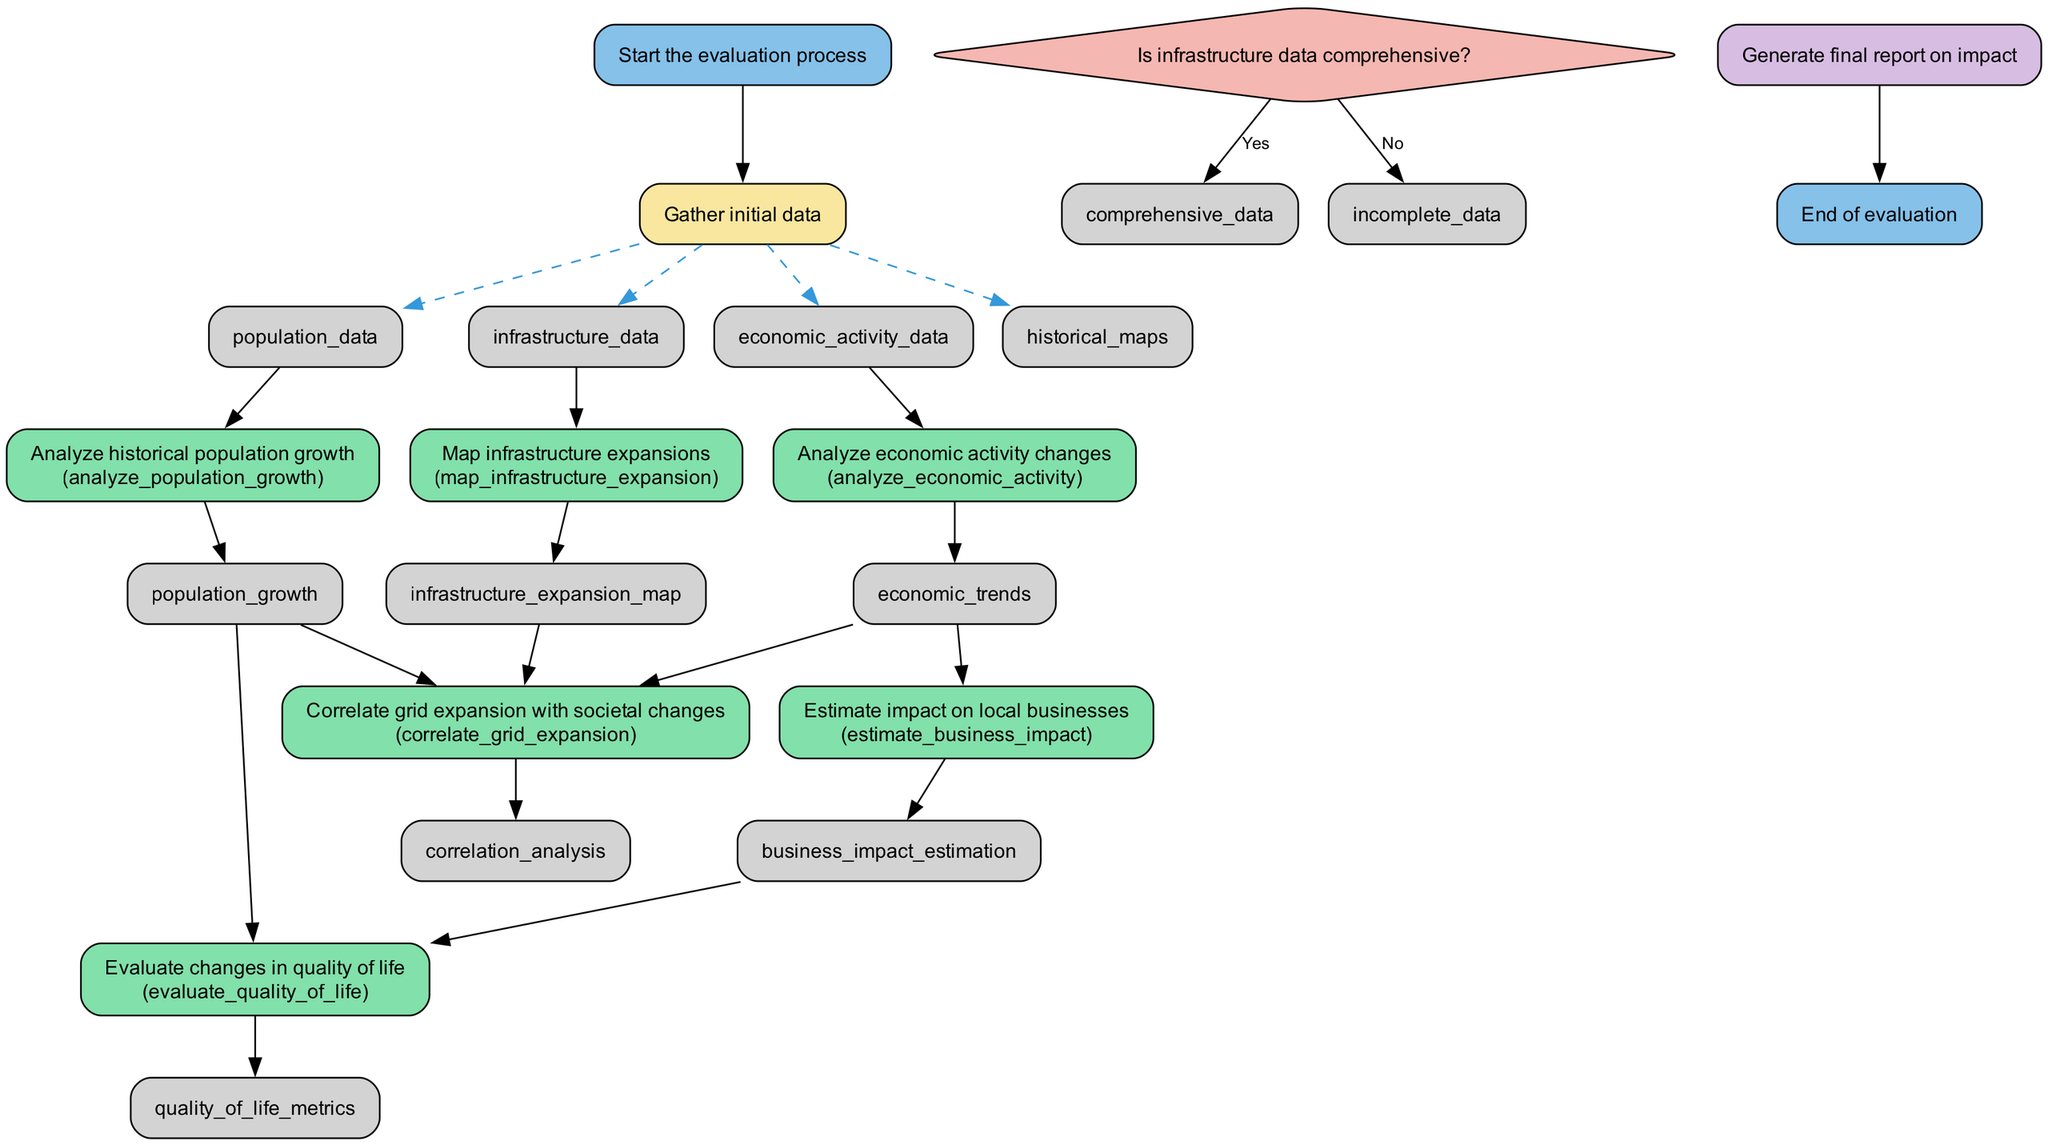What is the first step in the evaluation process? The first step in the evaluation process is to "Gather initial data." This is indicated as the first node following the start, which transitions directly from "Start the evaluation process."
Answer: Gather initial data How many types of nodes are present in the diagram? The diagram consists of five types of nodes: start, input, process, decision, and output. Each type is represented by different shapes and colors throughout the diagram.
Answer: Five What is the output of the "Analyze economic activity changes" process? The output of the "Analyze economic activity changes" process is "economic trends." This outcome is displayed as the output leading from the corresponding process node.
Answer: Economic trends What is the decision node in the diagram? The decision node in the diagram is "Is infrastructure data comprehensive?" This node determines the flow based on checking the comprehensiveness of infrastructure data.
Answer: Is infrastructure data comprehensive? Which two processes are inputs to the "Evaluate changes in quality of life"? The two processes that provide input to "Evaluate changes in quality of life" are "Analyze historical population growth" and "Estimate impact on local businesses." These inputs are shown leading into the quality of life evaluation.
Answer: Analyze historical population growth, Estimate impact on local businesses What happens if the infrastructure data is incomplete? If the infrastructure data is incomplete, the flow transitions to the node labeled "incomplete data." This is an outcome of the decision made at the "Is infrastructure data comprehensive?" node.
Answer: Incomplete data What is generated at the end of the evaluation process? At the end of the evaluation process, a "final report on impact" is generated. This is denoted as the output node that leads directly before the end of the evaluation.
Answer: Final report on impact How is grid expansion correlated with societal changes? Grid expansion is correlated with societal changes through the process "Correlate grid expansion with societal changes," which takes input from multiple sources: population growth, economic trends, and the infrastructure expansion map.
Answer: Correlate grid expansion with societal changes What input is required to "Estimate impact on local businesses"? The input required to "Estimate impact on local businesses" is "economic trends." This input comes directly from the previous process node of analyzing economic activity changes.
Answer: Economic trends 